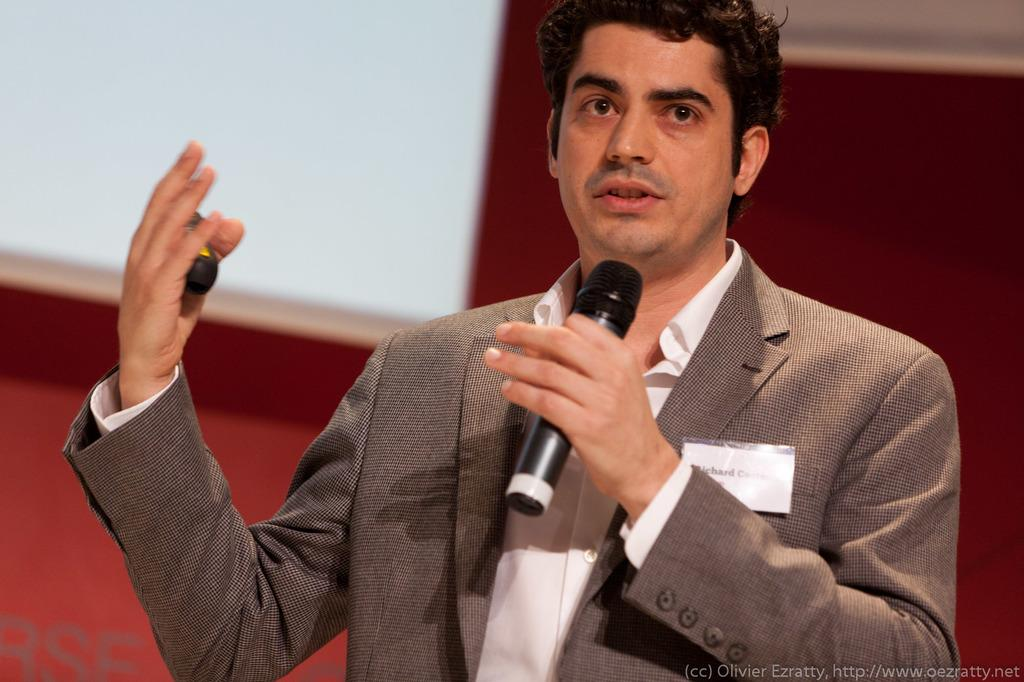What is the man in the image holding? The man is holding a mic. What is the man wearing in the image? The man is wearing a suit. What type of plastic material is the man using to deliver his speech in the image? There is no plastic material mentioned or visible in the image; the man is holding a mic, which is typically made of metal and plastic components. 